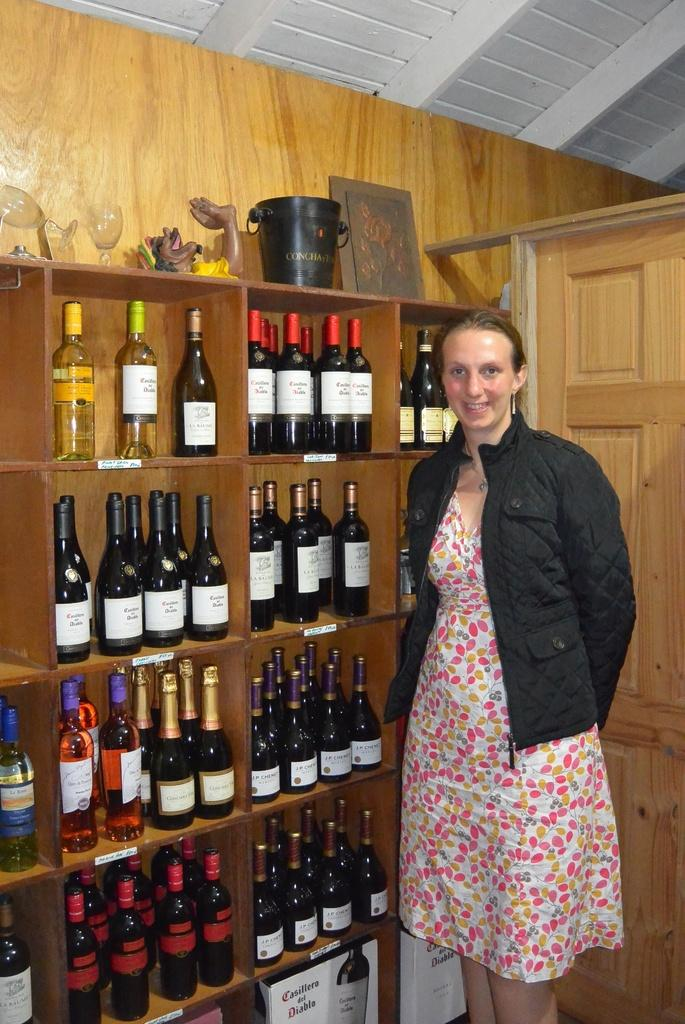Who is present in the image? There is a woman in the image. What is the woman wearing? The woman is wearing a black jacket. What is the woman's posture in the image? The woman is standing. What type of furniture can be seen in the image? There is a wooden shelf in the image. What items are related to drinking in the image? There is a bottle and wine glasses in the image. How many bells are hanging from the woman's jacket in the image? There are no bells present on the woman's jacket in the image. What type of dolls can be seen playing with the wine glasses in the image? There are no dolls present in the image, and the wine glasses are not being played with. 